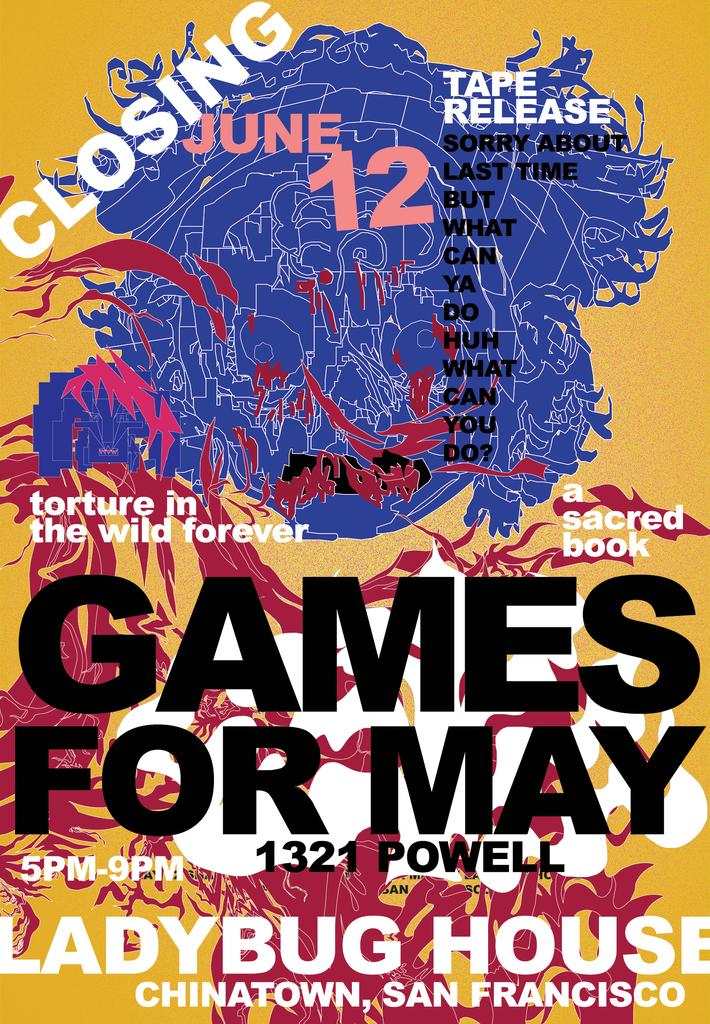<image>
Summarize the visual content of the image. A poster advertises an event called "Games for May." 